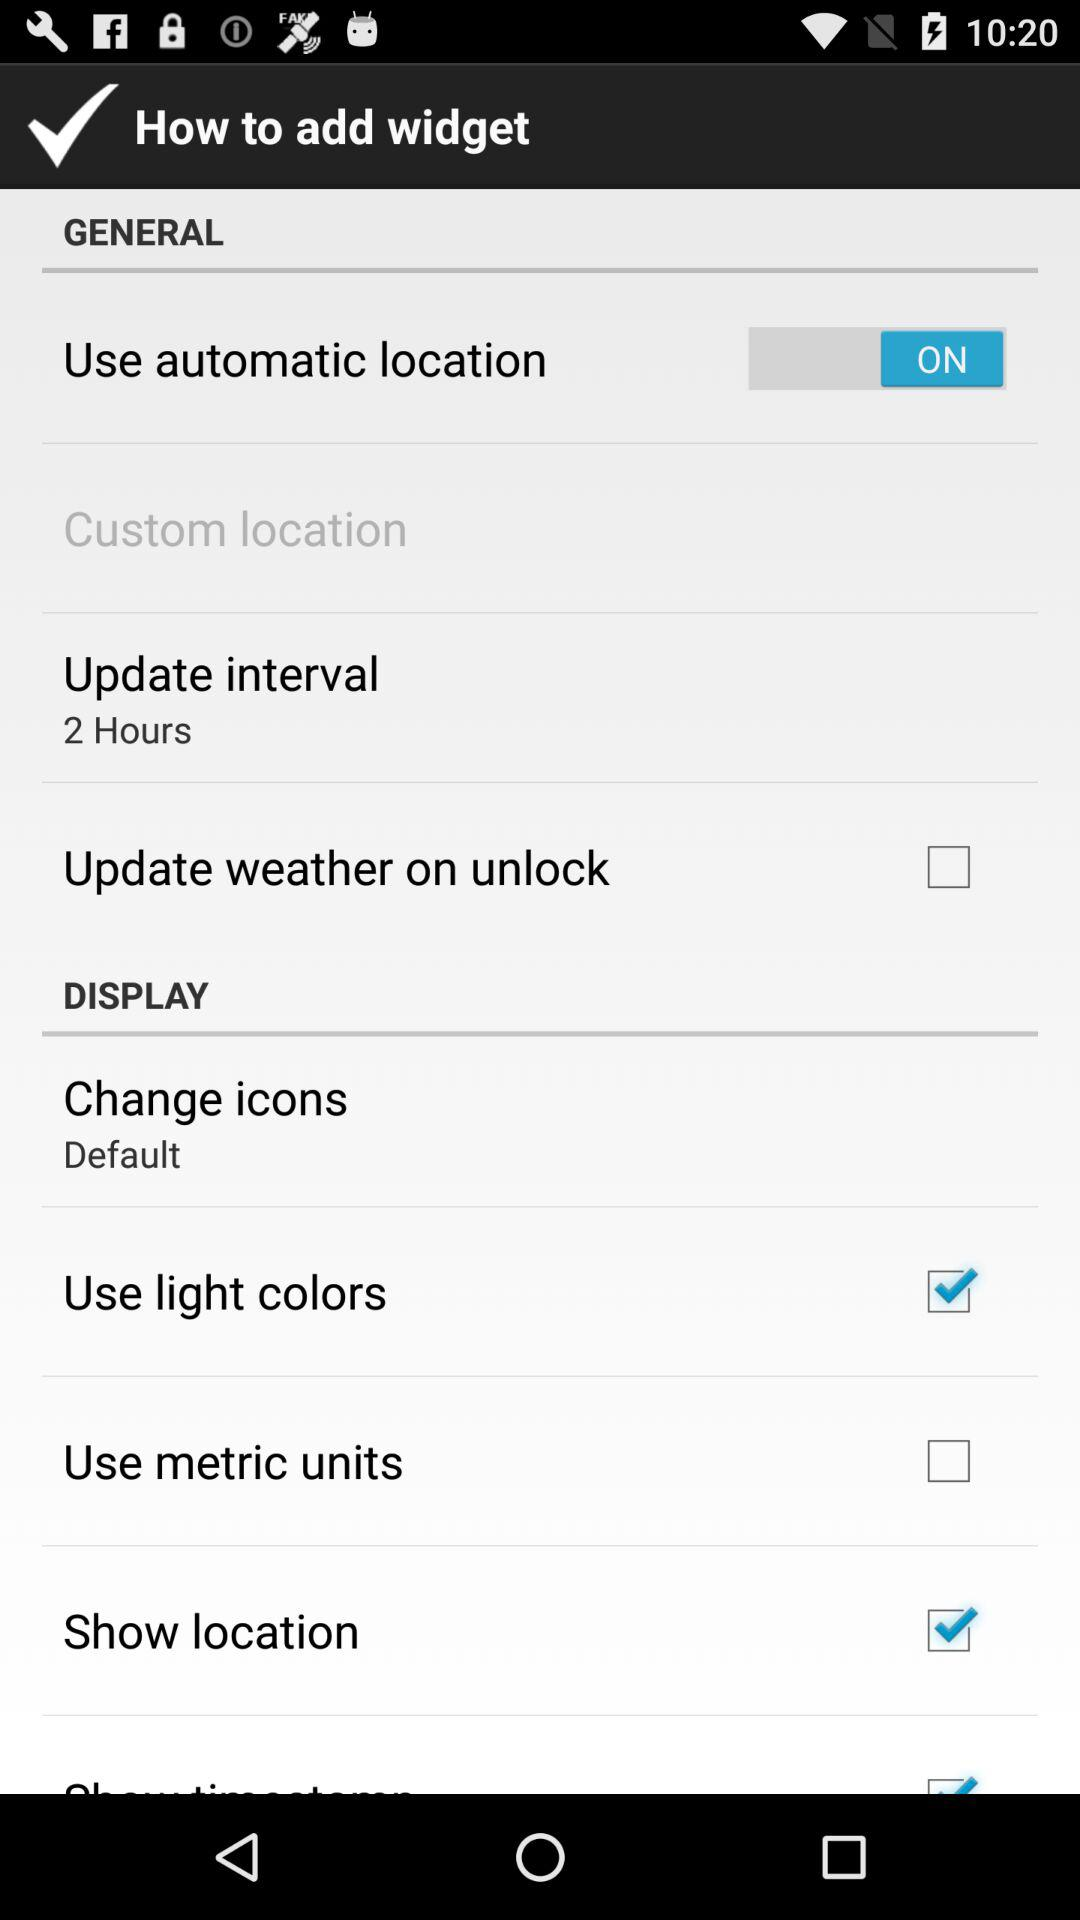What are the selected options for the Display Setting? The selected options are "Use light colors" and "Show location". 